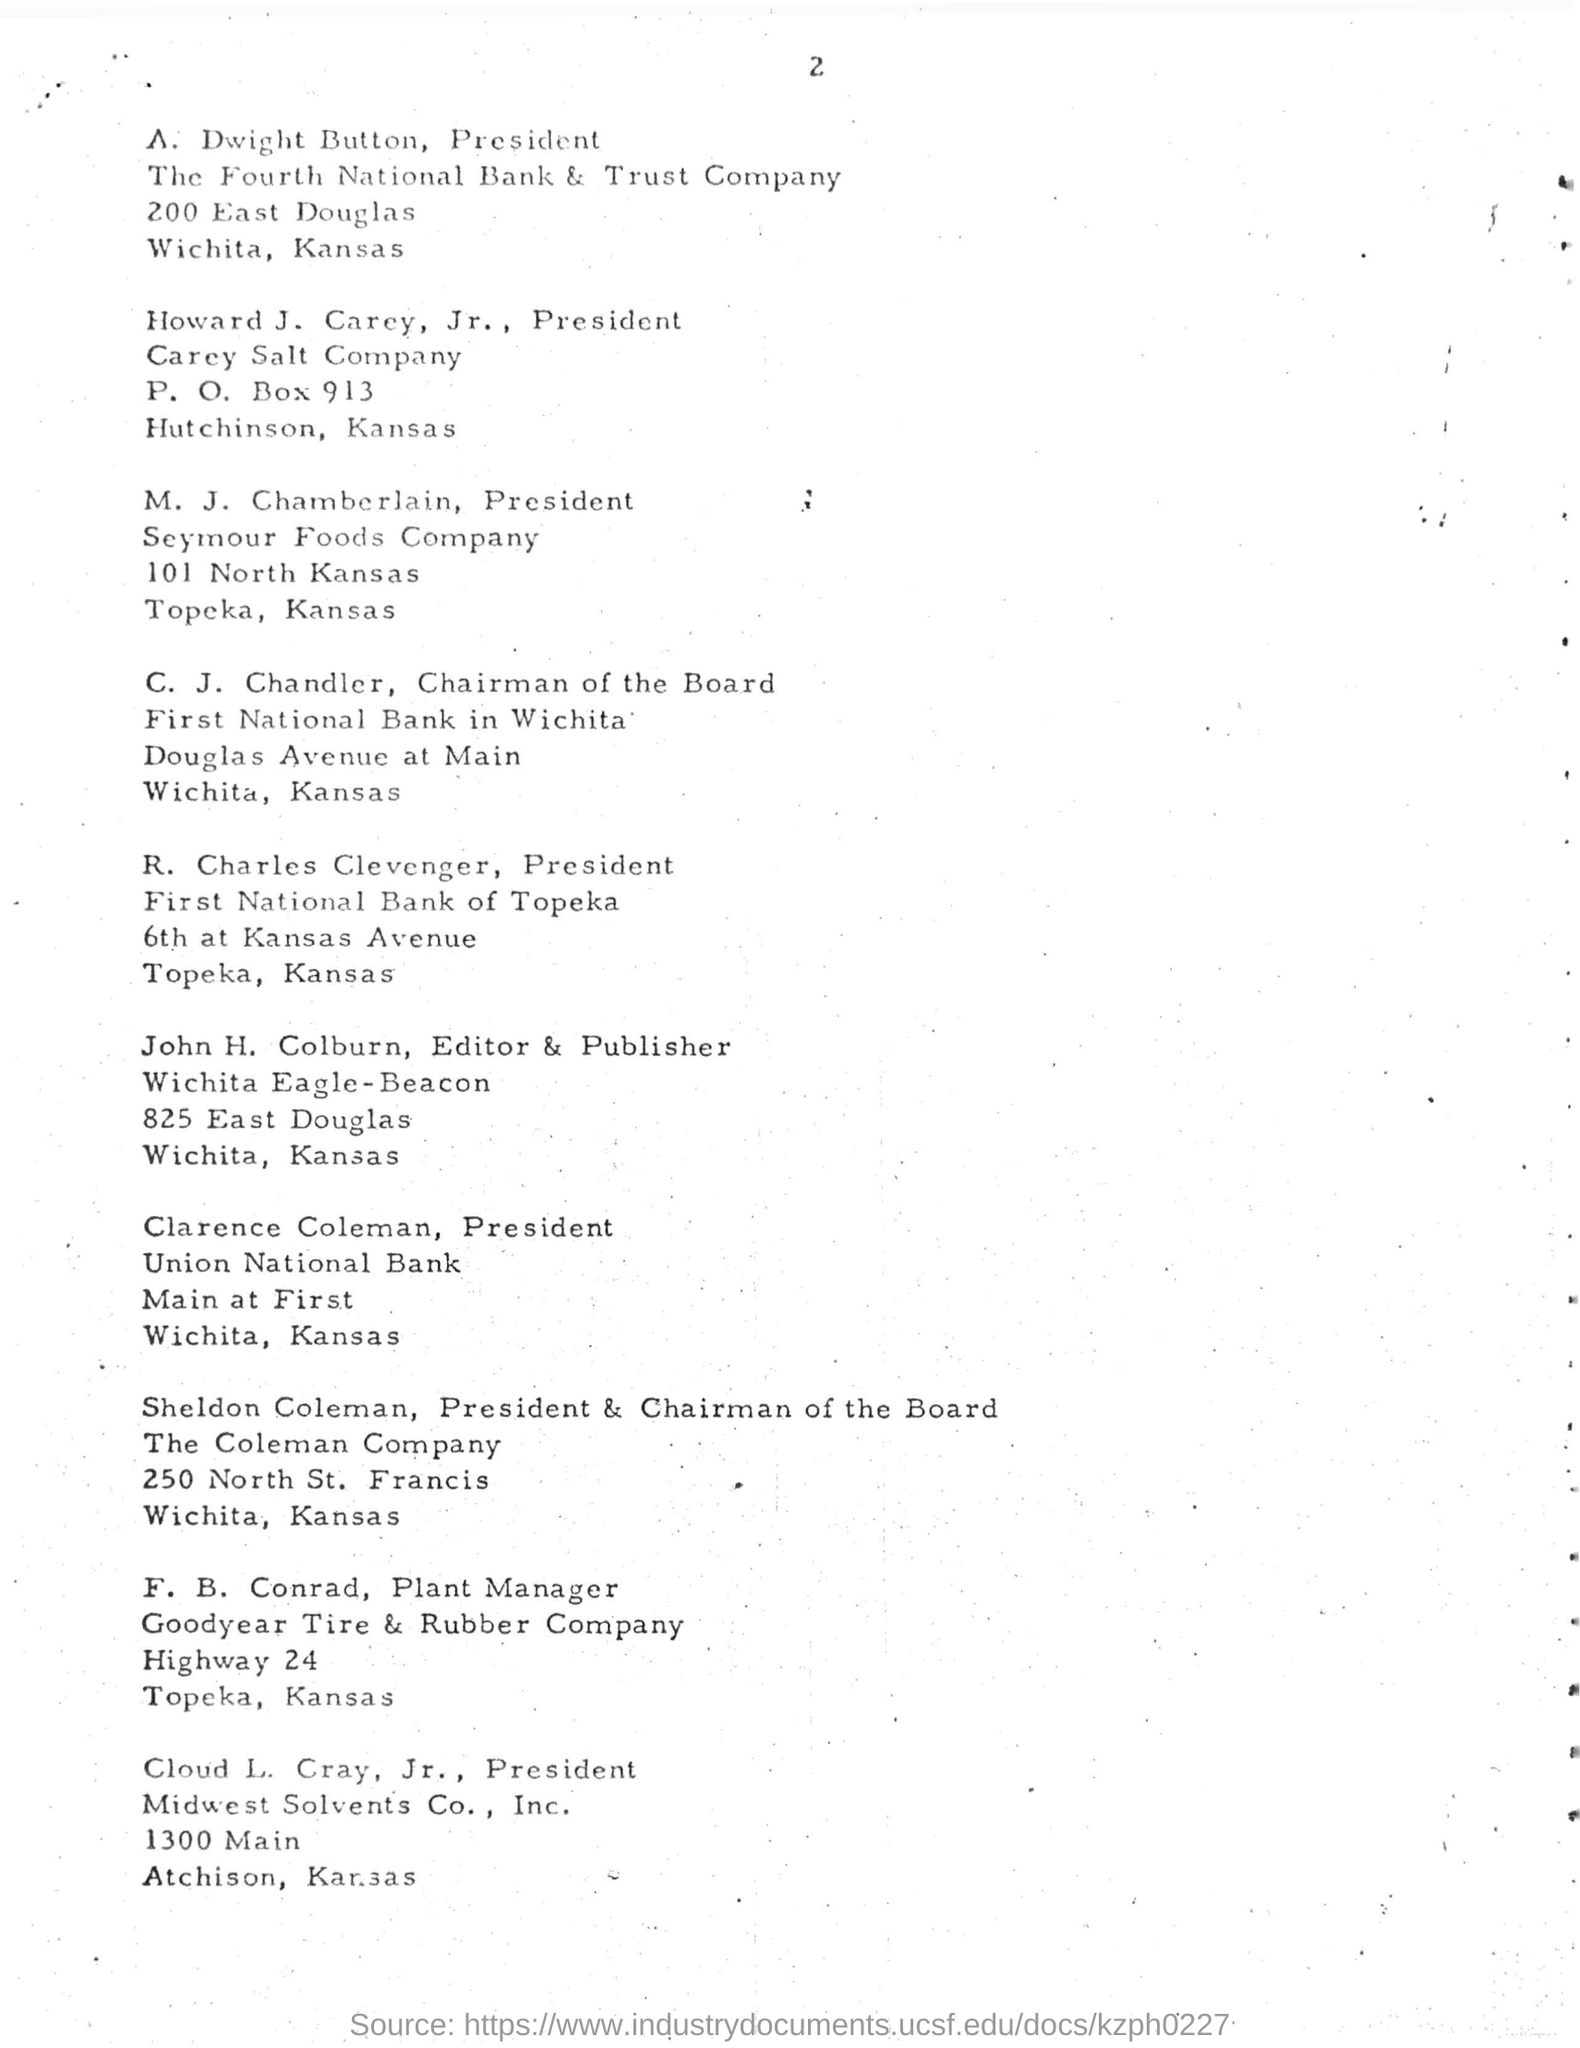Mention a couple of crucial points in this snapshot. The individual who holds the position of plant manager at Goodyear Tire and Rubber Company is F.B. Conrad. R. Charles Clevenger is the president of First National Bank of Topeka. Sheldon Coleman holds the position of president & chairman of the board at the Coleman Company. The President of Union National Bank is Clarence Coleman. A. Dwight button serves as the president of The Fourth National Bank & Trust Company. 